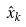<formula> <loc_0><loc_0><loc_500><loc_500>\hat { x } _ { k }</formula> 